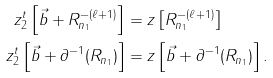<formula> <loc_0><loc_0><loc_500><loc_500>z _ { 2 } ^ { t } \left [ \vec { b } + R _ { n _ { 1 } } ^ { - ( \ell + 1 ) } \right ] & = z \left [ R _ { n _ { 1 } } ^ { - ( \ell + 1 ) } \right ] \\ z _ { 2 } ^ { t } \left [ \vec { b } + \partial ^ { - 1 } ( R _ { n _ { 1 } } ) \right ] & = z \left [ \vec { b } + \partial ^ { - 1 } ( R _ { n _ { 1 } } ) \right ] .</formula> 